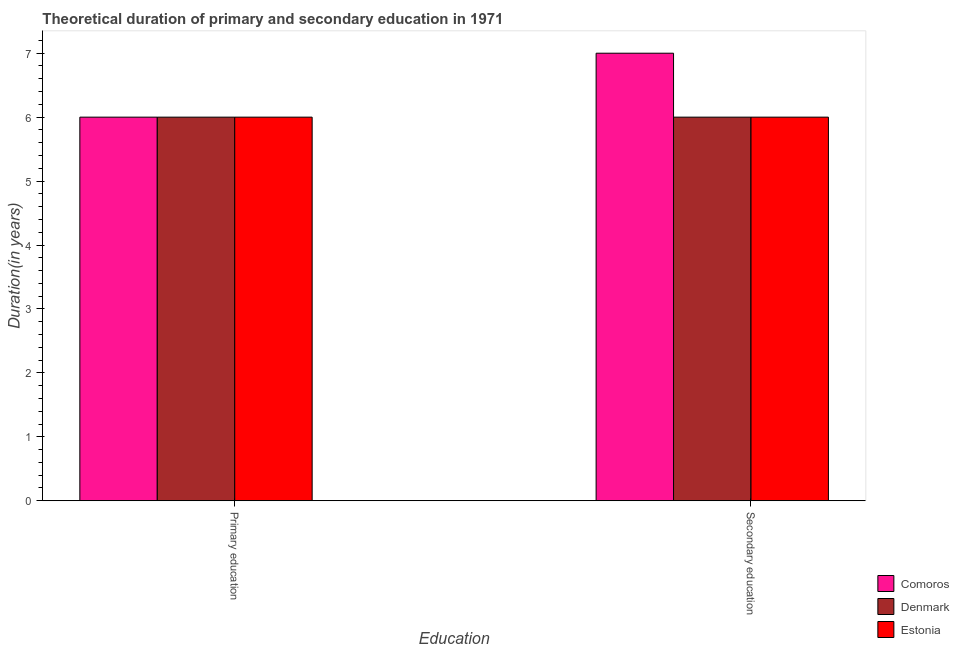How many different coloured bars are there?
Give a very brief answer. 3. How many groups of bars are there?
Give a very brief answer. 2. How many bars are there on the 1st tick from the left?
Make the answer very short. 3. How many bars are there on the 1st tick from the right?
Your answer should be very brief. 3. What is the duration of primary education in Comoros?
Your answer should be compact. 6. Across all countries, what is the maximum duration of primary education?
Your response must be concise. 6. Across all countries, what is the minimum duration of secondary education?
Make the answer very short. 6. In which country was the duration of secondary education maximum?
Offer a very short reply. Comoros. What is the total duration of secondary education in the graph?
Your answer should be very brief. 19. What is the difference between the duration of primary education in Estonia and that in Comoros?
Offer a very short reply. 0. What is the difference between the duration of primary education in Comoros and the duration of secondary education in Denmark?
Your answer should be compact. 0. What is the average duration of secondary education per country?
Offer a very short reply. 6.33. In how many countries, is the duration of secondary education greater than 0.2 years?
Make the answer very short. 3. Is the duration of secondary education in Comoros less than that in Denmark?
Offer a terse response. No. What does the 1st bar from the left in Secondary education represents?
Your answer should be compact. Comoros. What does the 1st bar from the right in Primary education represents?
Provide a short and direct response. Estonia. Are all the bars in the graph horizontal?
Offer a very short reply. No. What is the difference between two consecutive major ticks on the Y-axis?
Your answer should be very brief. 1. Does the graph contain grids?
Provide a short and direct response. No. How many legend labels are there?
Give a very brief answer. 3. What is the title of the graph?
Your answer should be compact. Theoretical duration of primary and secondary education in 1971. What is the label or title of the X-axis?
Your answer should be very brief. Education. What is the label or title of the Y-axis?
Provide a short and direct response. Duration(in years). What is the Duration(in years) of Denmark in Primary education?
Offer a very short reply. 6. What is the Duration(in years) of Comoros in Secondary education?
Make the answer very short. 7. What is the Duration(in years) of Denmark in Secondary education?
Keep it short and to the point. 6. Across all Education, what is the maximum Duration(in years) of Denmark?
Ensure brevity in your answer.  6. Across all Education, what is the maximum Duration(in years) in Estonia?
Your answer should be very brief. 6. Across all Education, what is the minimum Duration(in years) of Comoros?
Your response must be concise. 6. Across all Education, what is the minimum Duration(in years) in Estonia?
Keep it short and to the point. 6. What is the total Duration(in years) in Comoros in the graph?
Offer a very short reply. 13. What is the total Duration(in years) of Denmark in the graph?
Your answer should be compact. 12. What is the difference between the Duration(in years) in Comoros in Primary education and that in Secondary education?
Provide a succinct answer. -1. What is the difference between the Duration(in years) of Denmark in Primary education and that in Secondary education?
Provide a short and direct response. 0. What is the difference between the Duration(in years) of Estonia in Primary education and that in Secondary education?
Keep it short and to the point. 0. What is the difference between the Duration(in years) in Denmark in Primary education and the Duration(in years) in Estonia in Secondary education?
Make the answer very short. 0. What is the average Duration(in years) of Comoros per Education?
Keep it short and to the point. 6.5. What is the average Duration(in years) of Denmark per Education?
Give a very brief answer. 6. What is the average Duration(in years) of Estonia per Education?
Ensure brevity in your answer.  6. What is the difference between the Duration(in years) in Comoros and Duration(in years) in Denmark in Secondary education?
Your answer should be compact. 1. What is the difference between the Duration(in years) of Denmark and Duration(in years) of Estonia in Secondary education?
Give a very brief answer. 0. What is the ratio of the Duration(in years) in Comoros in Primary education to that in Secondary education?
Ensure brevity in your answer.  0.86. What is the ratio of the Duration(in years) in Denmark in Primary education to that in Secondary education?
Make the answer very short. 1. What is the difference between the highest and the second highest Duration(in years) of Comoros?
Offer a terse response. 1. What is the difference between the highest and the second highest Duration(in years) of Estonia?
Offer a very short reply. 0. What is the difference between the highest and the lowest Duration(in years) in Comoros?
Offer a terse response. 1. What is the difference between the highest and the lowest Duration(in years) of Denmark?
Offer a terse response. 0. What is the difference between the highest and the lowest Duration(in years) in Estonia?
Your response must be concise. 0. 